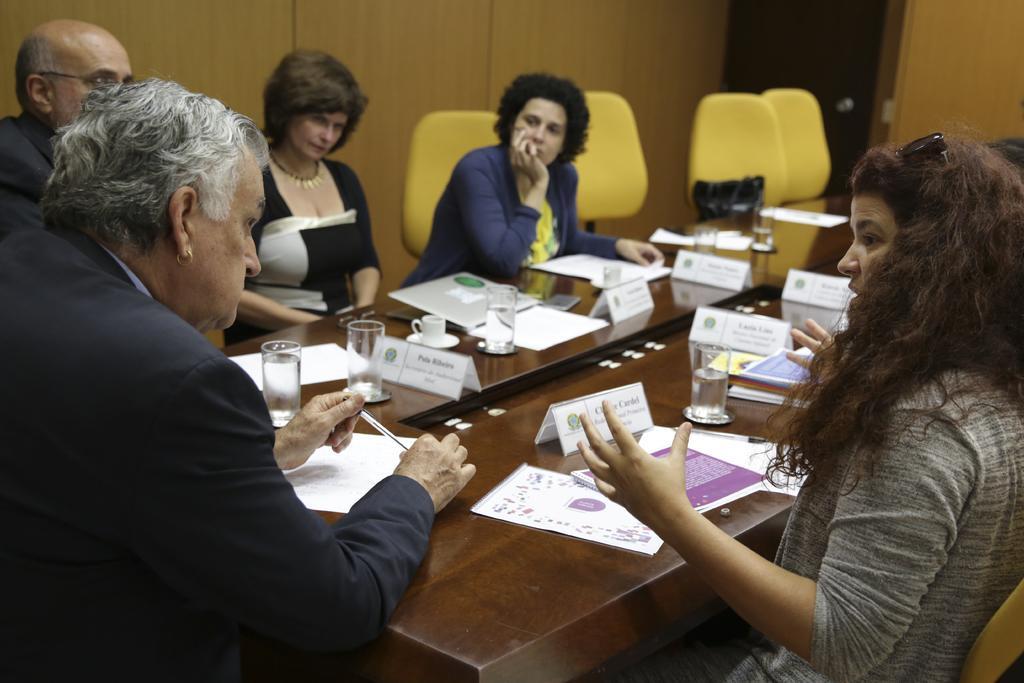Could you give a brief overview of what you see in this image? In the foreground of this image, there are people sitting around the table on which there are cups, glasses, mobile phones, name boards and papers. At the top, there is a wooden wall, door and few chairs. 